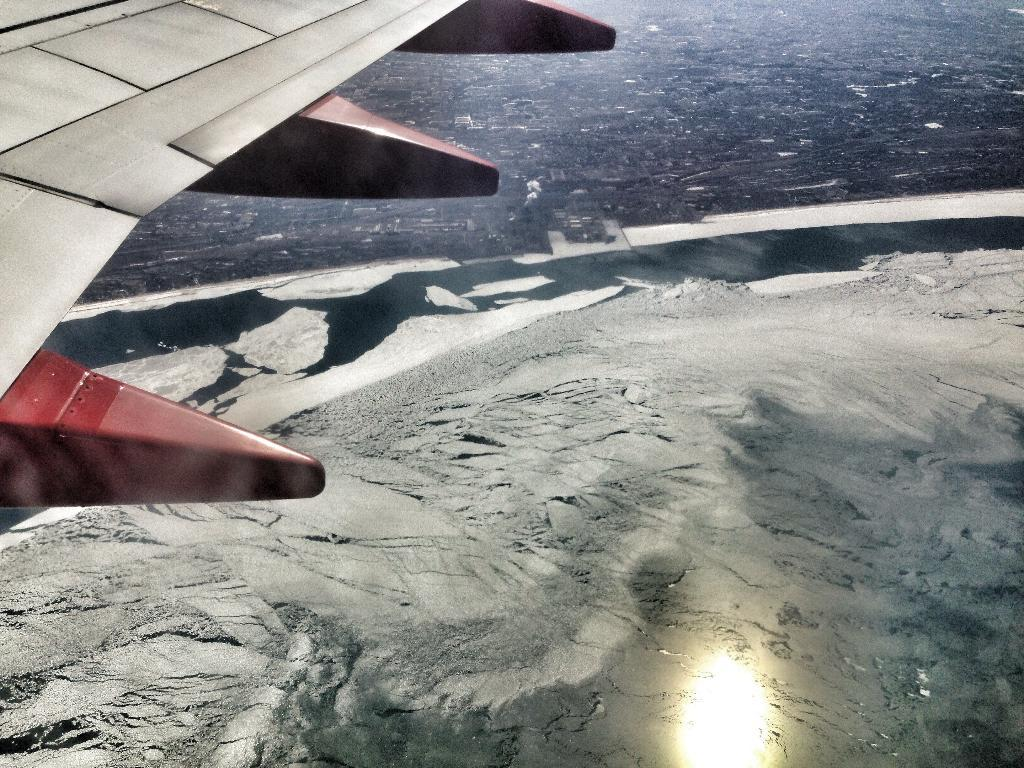What is the main subject of the image? The main subject of the image is an airplane flying. What can be seen below the airplane in the image? There is water visible at the bottom of the image. What is located at the top of the image? There are buildings on the land at the top of the image. What type of sheet is being used to cover the oven in the image? There is no sheet or oven present in the image; it features an airplane flying over water with buildings in the background. 